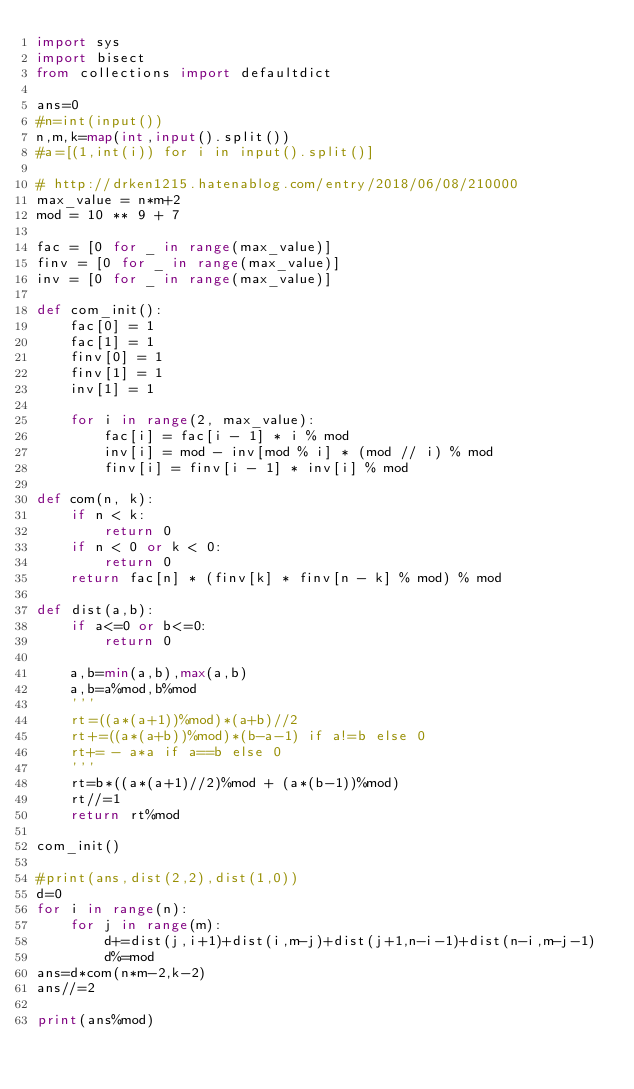<code> <loc_0><loc_0><loc_500><loc_500><_Python_>import sys
import bisect
from collections import defaultdict

ans=0
#n=int(input())
n,m,k=map(int,input().split())
#a=[(1,int(i)) for i in input().split()]

# http://drken1215.hatenablog.com/entry/2018/06/08/210000
max_value = n*m+2
mod = 10 ** 9 + 7

fac = [0 for _ in range(max_value)]
finv = [0 for _ in range(max_value)]
inv = [0 for _ in range(max_value)]

def com_init():
    fac[0] = 1
    fac[1] = 1
    finv[0] = 1
    finv[1] = 1
    inv[1] = 1

    for i in range(2, max_value):
        fac[i] = fac[i - 1] * i % mod
        inv[i] = mod - inv[mod % i] * (mod // i) % mod
        finv[i] = finv[i - 1] * inv[i] % mod

def com(n, k):
    if n < k:
        return 0
    if n < 0 or k < 0:
        return 0
    return fac[n] * (finv[k] * finv[n - k] % mod) % mod

def dist(a,b):
    if a<=0 or b<=0:
        return 0
    
    a,b=min(a,b),max(a,b)
    a,b=a%mod,b%mod
    '''
    rt=((a*(a+1))%mod)*(a+b)//2
    rt+=((a*(a+b))%mod)*(b-a-1) if a!=b else 0
    rt+= - a*a if a==b else 0
    '''
    rt=b*((a*(a+1)//2)%mod + (a*(b-1))%mod)
    rt//=1
    return rt%mod

com_init()

#print(ans,dist(2,2),dist(1,0))
d=0
for i in range(n):
    for j in range(m):
        d+=dist(j,i+1)+dist(i,m-j)+dist(j+1,n-i-1)+dist(n-i,m-j-1)
        d%=mod
ans=d*com(n*m-2,k-2)
ans//=2

print(ans%mod)
        
        </code> 